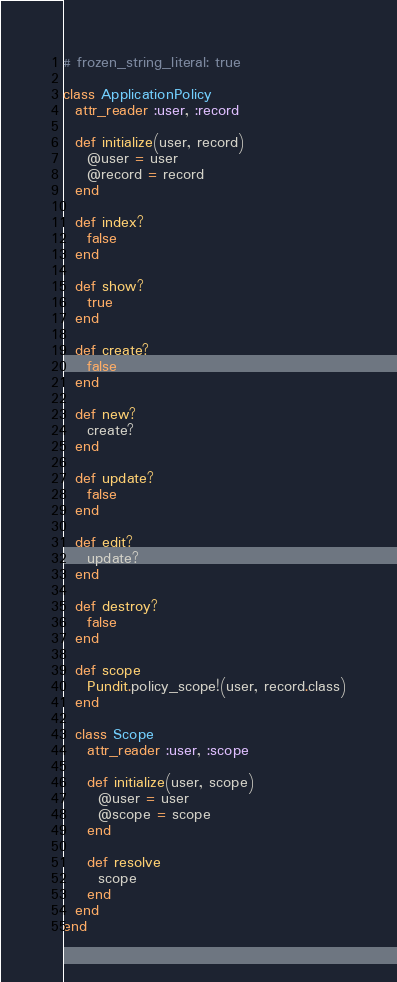<code> <loc_0><loc_0><loc_500><loc_500><_Ruby_># frozen_string_literal: true

class ApplicationPolicy
  attr_reader :user, :record

  def initialize(user, record)
    @user = user
    @record = record
  end

  def index?
    false
  end

  def show?
    true
  end

  def create?
    false
  end

  def new?
    create?
  end

  def update?
    false
  end

  def edit?
    update?
  end

  def destroy?
    false
  end

  def scope
    Pundit.policy_scope!(user, record.class)
  end

  class Scope
    attr_reader :user, :scope

    def initialize(user, scope)
      @user = user
      @scope = scope
    end

    def resolve
      scope
    end
  end
end
</code> 